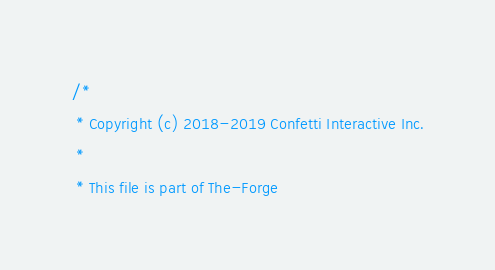Convert code to text. <code><loc_0><loc_0><loc_500><loc_500><_ObjectiveC_>/*
 * Copyright (c) 2018-2019 Confetti Interactive Inc.
 *
 * This file is part of The-Forge</code> 